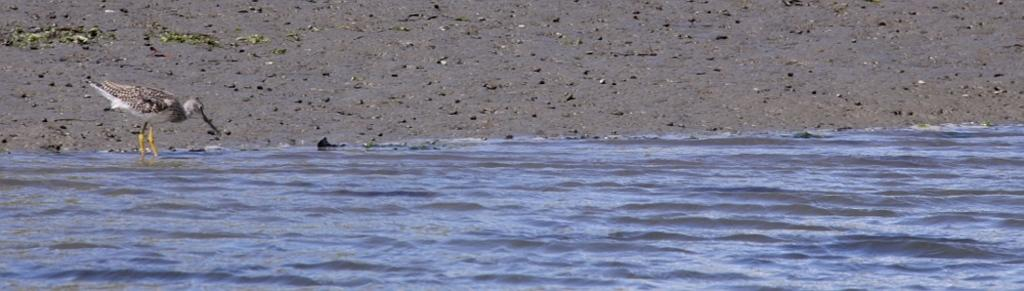What type of animal can be seen in the image? There is a bird in the image. Where is the bird located in the image? The bird is standing in the water. What can be observed about the water in the image? There are ripples in the water. What is visible besides the water in the image? There is land visible in the image. What can be found on the land in the image? There are stones on the land. What type of mark does the bird leave on the stones in the image? There is no indication in the image that the bird leaves any marks on the stones. 